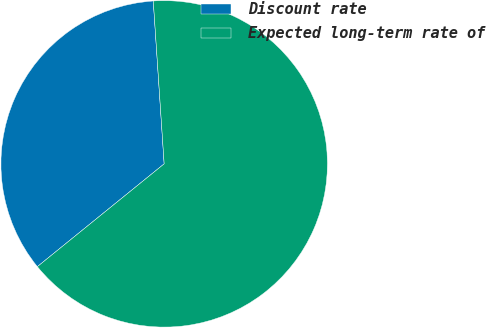Convert chart. <chart><loc_0><loc_0><loc_500><loc_500><pie_chart><fcel>Discount rate<fcel>Expected long-term rate of<nl><fcel>34.78%<fcel>65.22%<nl></chart> 